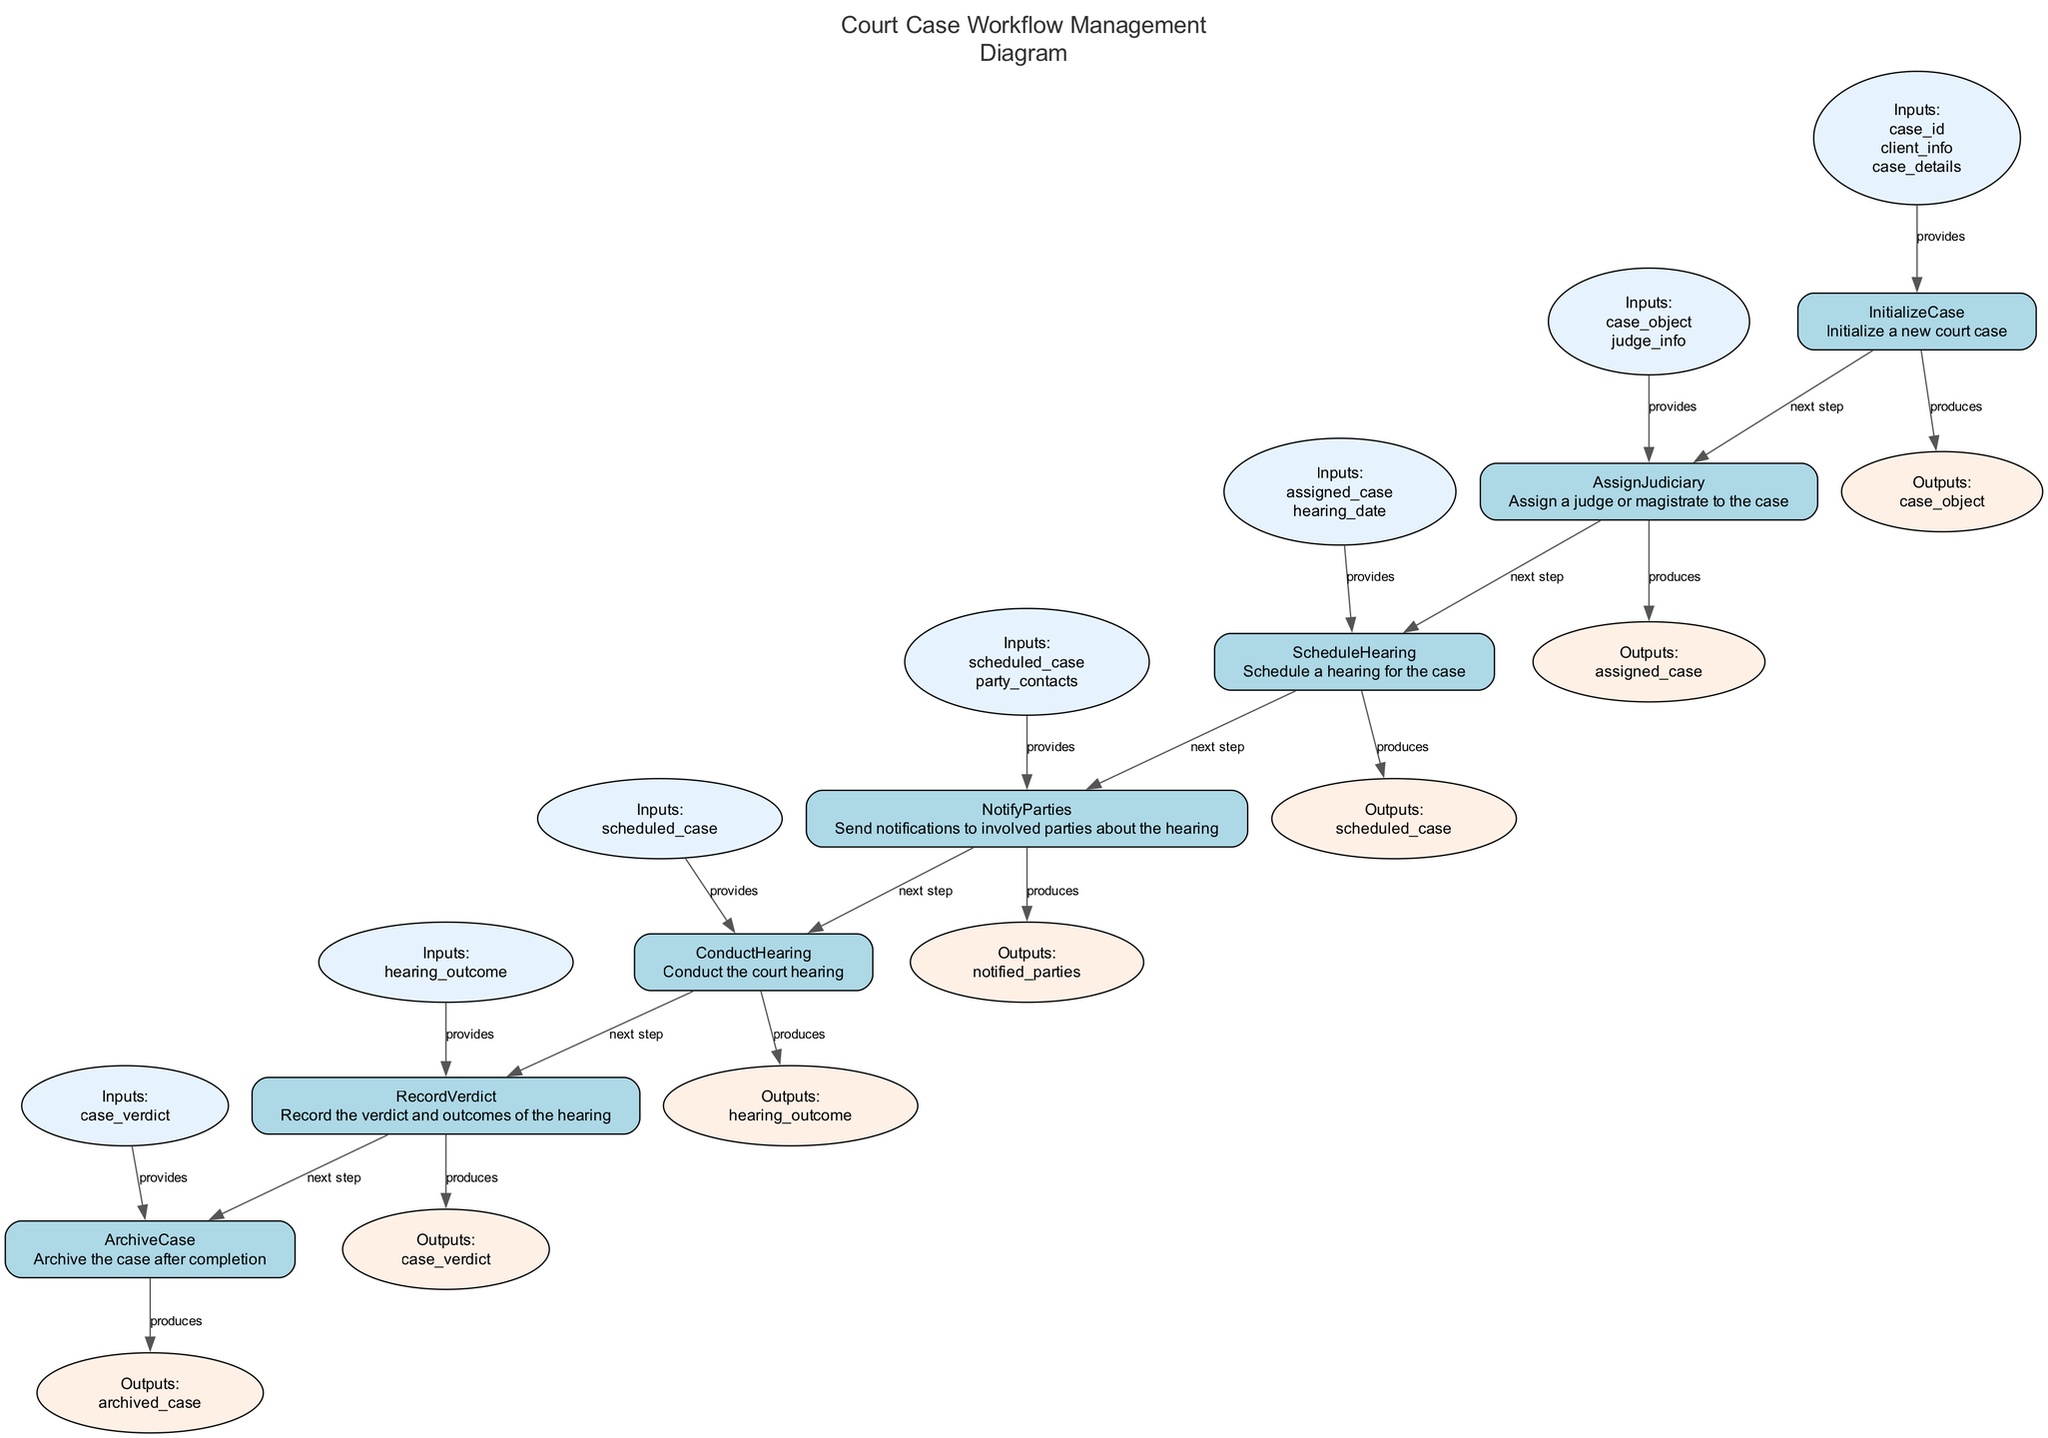What is the first function in the workflow? The diagram starts with the "InitializeCase" function, which is the first node representing the initiation of a new court case.
Answer: InitializeCase How many outputs does the "ScheduleHearing" function produce? The "ScheduleHearing" function produces one output, labeled as "scheduled_case," which can be observed in the outputs section of that node.
Answer: one What is the last function executed in the workflow? The final function in the workflow is "ArchiveCase," signified by its position at the end of the flowchart and there are no subsequent nodes following it.
Answer: ArchiveCase Which function sends notifications to involved parties? According to the diagram, the function responsible for sending notifications is "NotifyParties," as indicated by its description and definition in the workflow sequence.
Answer: NotifyParties How many total functions are represented in this workflow? There are seven distinct functions in total as shown by the number of nodes labeled accordingly in the diagram.
Answer: seven What is the output of the "RecordVerdict" function? The "RecordVerdict" function produces the output called "case_verdict," which is explicitly mentioned in the outputs section associated with that function node.
Answer: case_verdict What comes after "ConductHearing" in the workflow? Following "ConductHearing," the next function in the sequence is "RecordVerdict," which can be determined by tracing the directed edge that connects these two nodes in the diagram.
Answer: RecordVerdict Name the input required for the "AssignJudiciary" function. The function "AssignJudiciary" requires two inputs: "case_object" and "judge_info," which are highlighted in that function's inputs section within the diagram.
Answer: case_object, judge_info Which function follows "NotifyParties"? The function that comes directly after "NotifyParties" in the flowchart is "ConductHearing," shown by the flow connecting these two nodes sequentially.
Answer: ConductHearing 